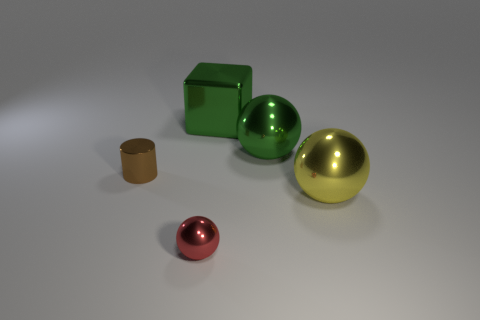What material is the tiny ball?
Give a very brief answer. Metal. What color is the metal cylinder?
Offer a very short reply. Brown. What is the color of the thing that is both behind the red shiny object and in front of the tiny brown thing?
Provide a short and direct response. Yellow. Is there anything else that is made of the same material as the green cube?
Give a very brief answer. Yes. Are the large yellow object and the tiny object that is in front of the large yellow metal object made of the same material?
Keep it short and to the point. Yes. There is a metallic ball that is behind the object that is on the left side of the red thing; what size is it?
Keep it short and to the point. Large. Is there anything else that has the same color as the tiny sphere?
Keep it short and to the point. No. Are the ball on the left side of the big green metallic ball and the ball that is behind the big yellow thing made of the same material?
Provide a short and direct response. Yes. The object that is both left of the green metal block and behind the small metallic ball is made of what material?
Your answer should be very brief. Metal. Is the shape of the large yellow shiny object the same as the thing that is left of the tiny ball?
Ensure brevity in your answer.  No. 